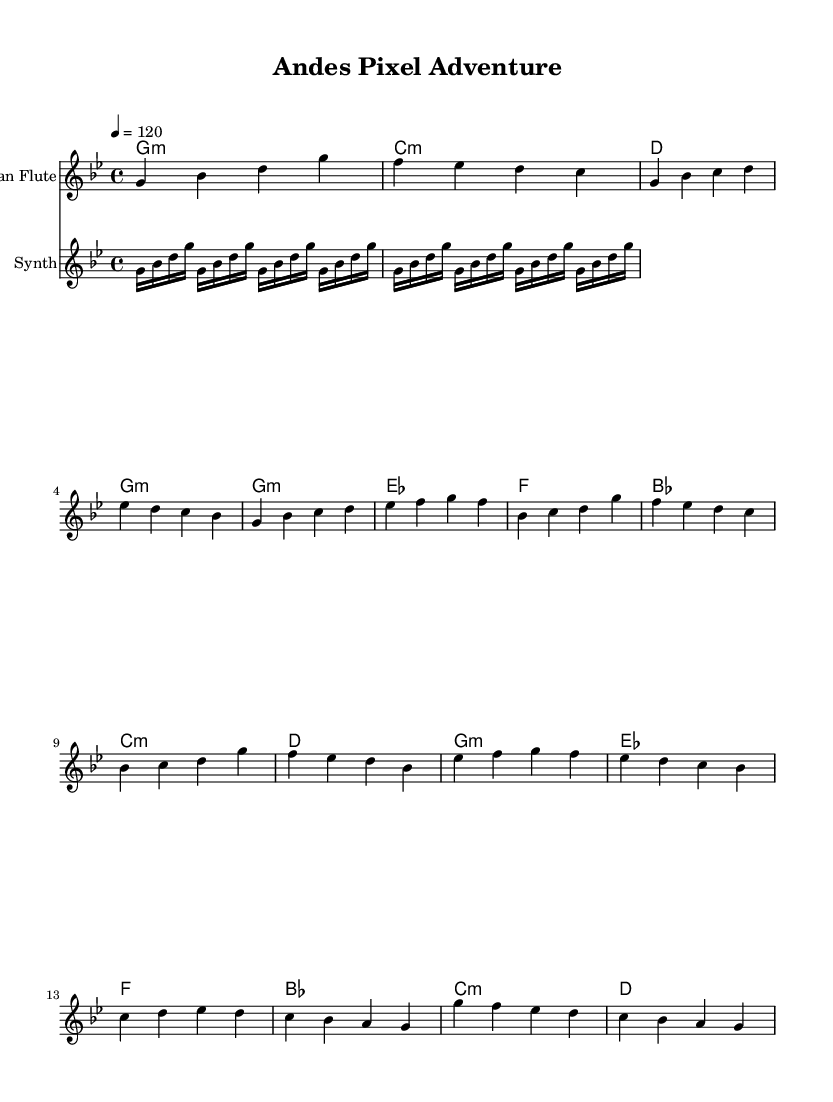What is the key signature of this music? The key signature is G minor, which has two flats (B flat and E flat). This can be inferred from the "key g minor" designation in the global variable section of the code.
Answer: G minor What is the time signature of this music? The time signature is 4/4, as indicated by the "time 4/4" declaration in the global variable. This means there are four beats in each measure and the quarter note gets one beat.
Answer: 4/4 What is the tempo marking for this music? The tempo marking is 120 beats per minute, specified by the "tempo 4 = 120" statement in the global section. This indicates how fast the music should be played.
Answer: 120 How many measures are in the verse section? The verse section consists of two measures, as seen in the notation with the following groups of notes: "g4 bes c d es d c bes" is one measure and "g4 bes c d es f g f" is the second.
Answer: 2 What instrument plays the arpeggiated pattern? The instrument playing the arpeggiated pattern is the synth, as indicated by the instrument name set in the related section of the code. The synth part is specifically labeled and includes the repeated arpeggios.
Answer: Synth Which chord follows the G minor chord in the progression? The chord that follows the G minor chord is C minor, as seen in the chord names section where the progression lists G minor first followed by C minor, making it the next chord to be played.
Answer: C minor How many times is the synth pattern repeated? The synth pattern is repeated eight times, as indicated by the "repeat unfold 8" directive. This shows that the arpeggiated synth pattern is to be played multiple times to create a layered effect.
Answer: 8 